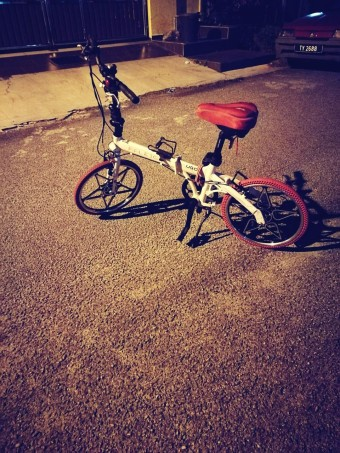What type of bicycle is shown in the image, and what are some of its features? The image shows a foldable bicycle, identifiable by the hinge in the frame that allows it to be folded. It has a red saddle, a derailleur gear system, and appears to be designed for convenient urban travel. 